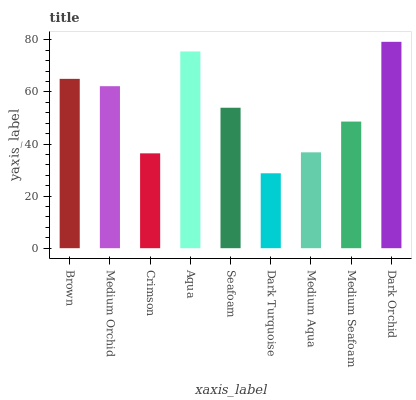Is Dark Turquoise the minimum?
Answer yes or no. Yes. Is Dark Orchid the maximum?
Answer yes or no. Yes. Is Medium Orchid the minimum?
Answer yes or no. No. Is Medium Orchid the maximum?
Answer yes or no. No. Is Brown greater than Medium Orchid?
Answer yes or no. Yes. Is Medium Orchid less than Brown?
Answer yes or no. Yes. Is Medium Orchid greater than Brown?
Answer yes or no. No. Is Brown less than Medium Orchid?
Answer yes or no. No. Is Seafoam the high median?
Answer yes or no. Yes. Is Seafoam the low median?
Answer yes or no. Yes. Is Medium Seafoam the high median?
Answer yes or no. No. Is Aqua the low median?
Answer yes or no. No. 